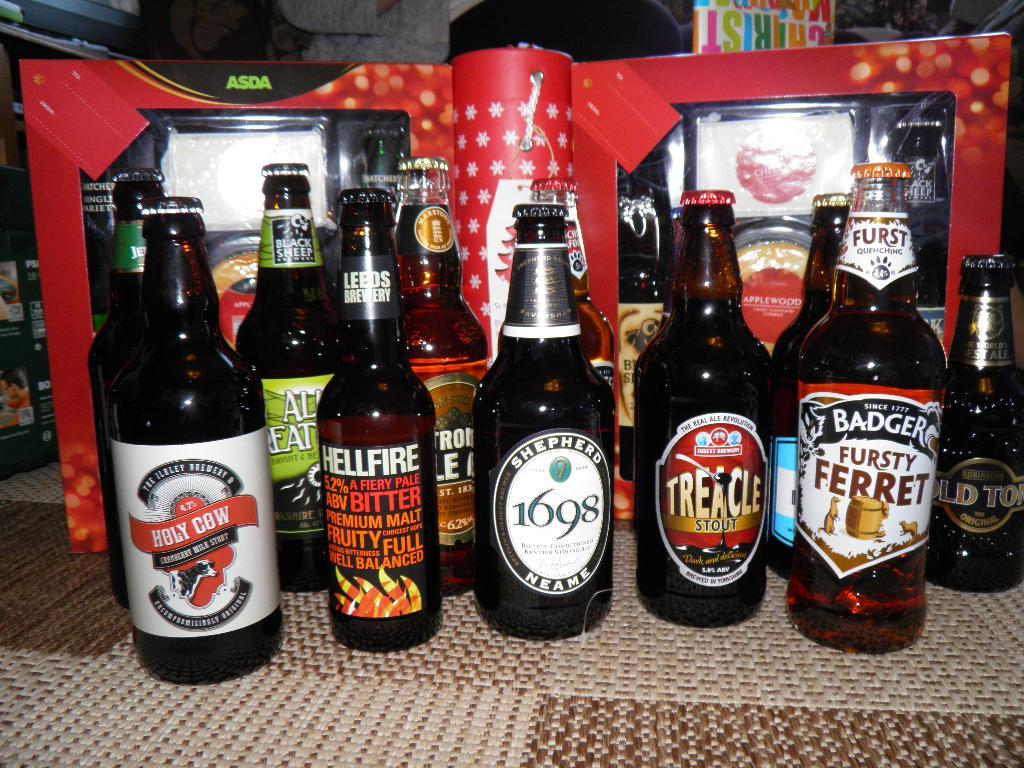<image>
Share a concise interpretation of the image provided. Multiple bottles of beer including Holy Cow Cranberry Milk Stout on a table. 